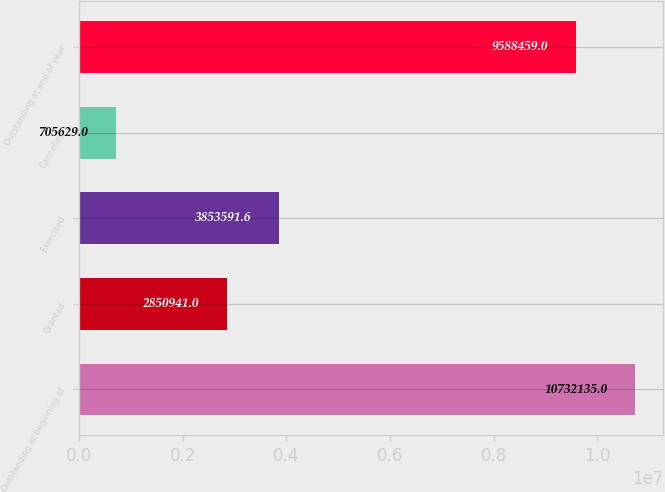Convert chart to OTSL. <chart><loc_0><loc_0><loc_500><loc_500><bar_chart><fcel>Outstanding at beginning of<fcel>Granted<fcel>Exercised<fcel>Cancelled<fcel>Outstanding at end of year<nl><fcel>1.07321e+07<fcel>2.85094e+06<fcel>3.85359e+06<fcel>705629<fcel>9.58846e+06<nl></chart> 